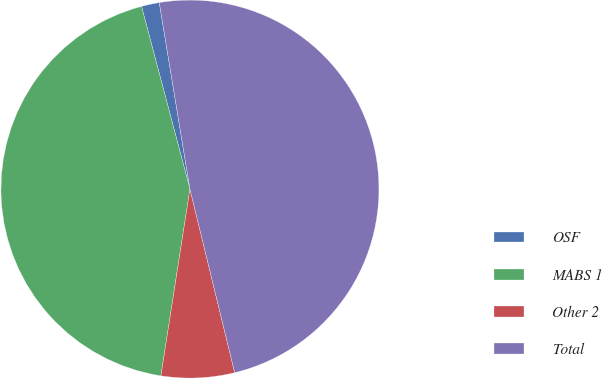Convert chart to OTSL. <chart><loc_0><loc_0><loc_500><loc_500><pie_chart><fcel>OSF<fcel>MABS 1<fcel>Other 2<fcel>Total<nl><fcel>1.53%<fcel>43.42%<fcel>6.26%<fcel>48.79%<nl></chart> 